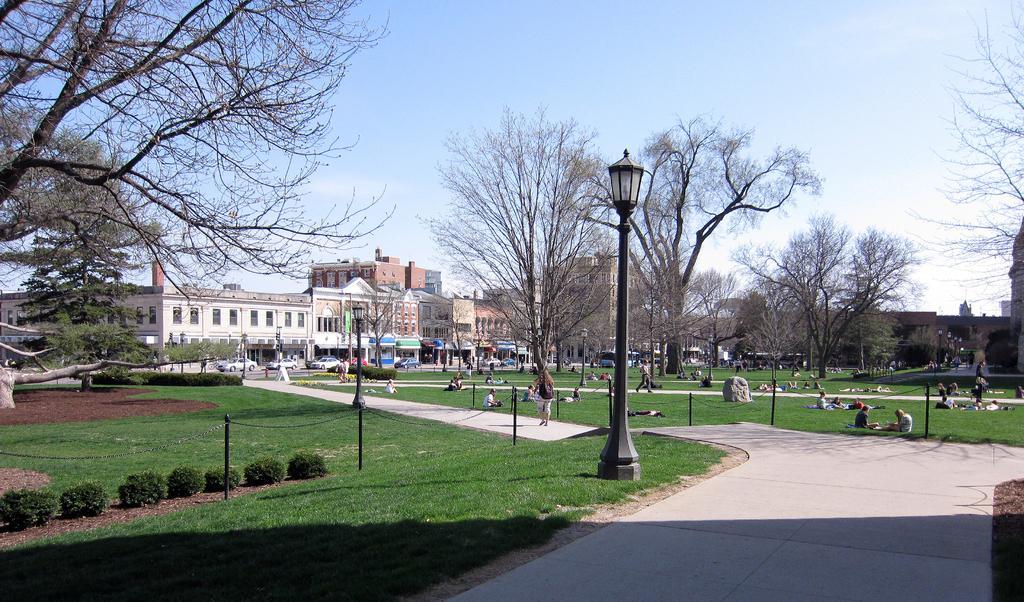Could you give a brief overview of what you see in this image? In this image I can see the road, some grass, few plants, few black colored poles, a street light and few trees. In the background I can see few persons sitting on the grass, few persons walking on the paths, few buildings, few vehicles, few trees and the sky. 